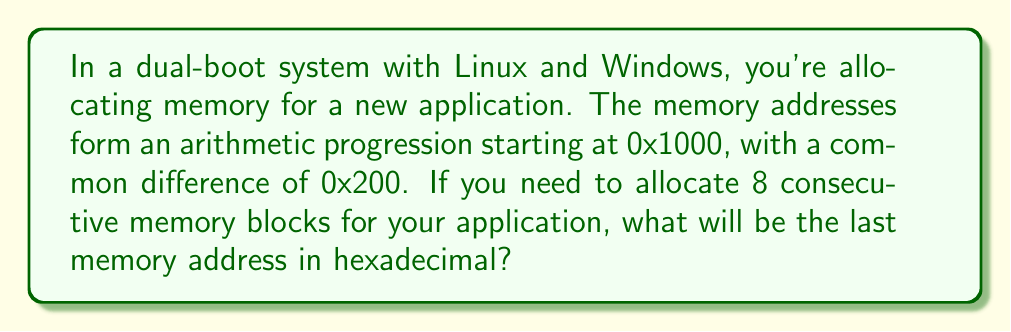Can you solve this math problem? Let's approach this step-by-step:

1) We're dealing with an arithmetic progression where:
   - First term (a₁) = 0x1000
   - Common difference (d) = 0x200
   - Number of terms (n) = 8

2) The formula for the nth term of an arithmetic progression is:
   $$a_n = a_1 + (n-1)d$$

3) Substituting our values:
   $$a_8 = 0x1000 + (8-1)(0x200)$$

4) Simplify:
   $$a_8 = 0x1000 + 7(0x200)$$

5) To add hexadecimal numbers, we convert to decimal, add, then convert back:
   0x1000 = 4096
   0x200 = 512
   7 * 512 = 3584
   4096 + 3584 = 7680

6) Convert 7680 back to hexadecimal:
   7680 ÷ 16 = 480 remainder 0
   480 ÷ 16 = 30 remainder 0
   30 ÷ 16 = 1 remainder 14 (E in hex)
   1 ÷ 16 = 0 remainder 1

   Reading from bottom to top: 0x1E00

Therefore, the last memory address in the sequence is 0x1E00.
Answer: 0x1E00 